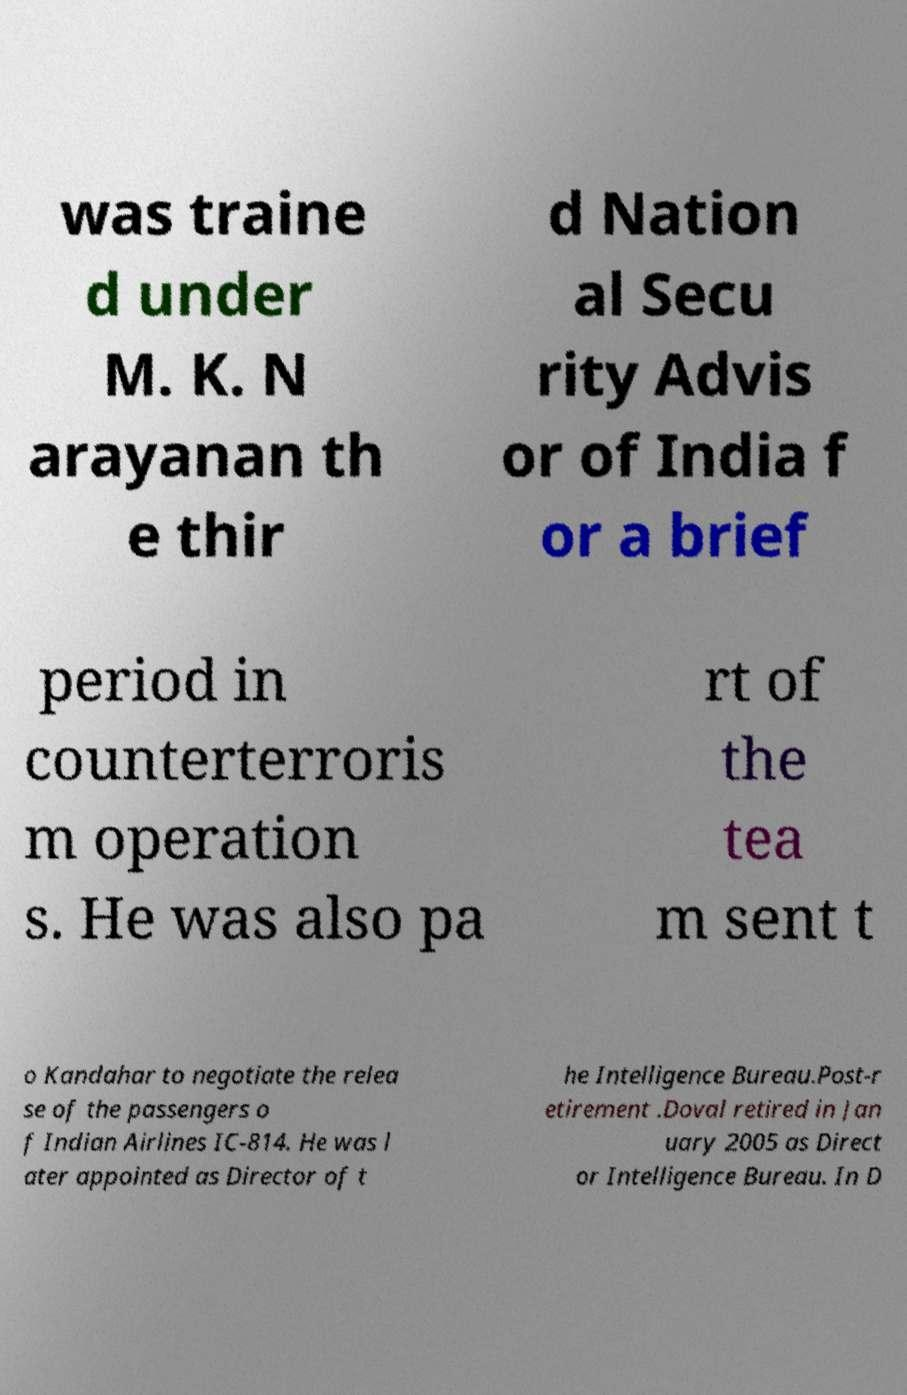There's text embedded in this image that I need extracted. Can you transcribe it verbatim? was traine d under M. K. N arayanan th e thir d Nation al Secu rity Advis or of India f or a brief period in counterterroris m operation s. He was also pa rt of the tea m sent t o Kandahar to negotiate the relea se of the passengers o f Indian Airlines IC-814. He was l ater appointed as Director of t he Intelligence Bureau.Post-r etirement .Doval retired in Jan uary 2005 as Direct or Intelligence Bureau. In D 